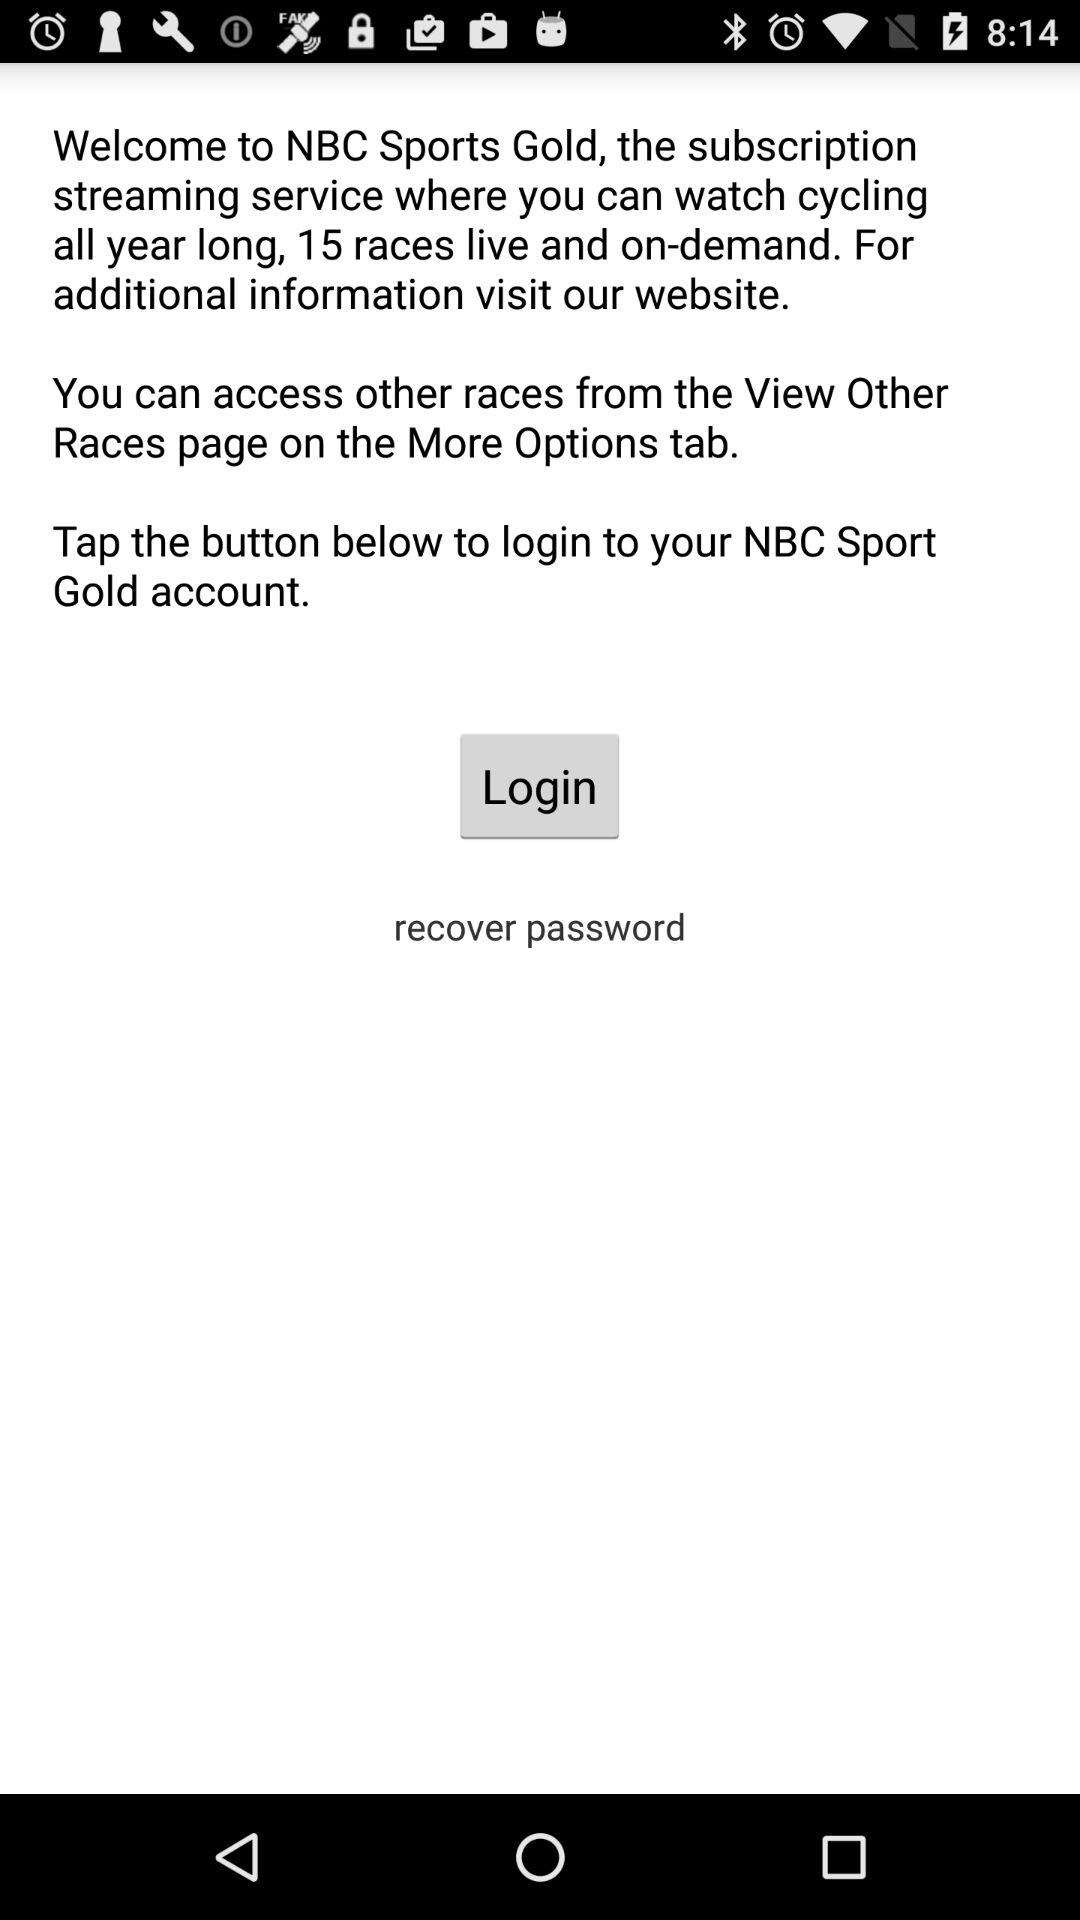What account can be used to login? The account that can be used to login is the "NBC Sport Gold account". 